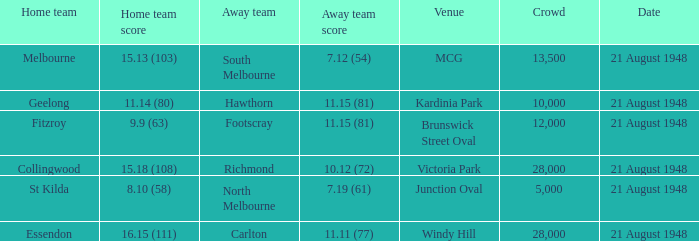With a home team score of 1 28000.0. Write the full table. {'header': ['Home team', 'Home team score', 'Away team', 'Away team score', 'Venue', 'Crowd', 'Date'], 'rows': [['Melbourne', '15.13 (103)', 'South Melbourne', '7.12 (54)', 'MCG', '13,500', '21 August 1948'], ['Geelong', '11.14 (80)', 'Hawthorn', '11.15 (81)', 'Kardinia Park', '10,000', '21 August 1948'], ['Fitzroy', '9.9 (63)', 'Footscray', '11.15 (81)', 'Brunswick Street Oval', '12,000', '21 August 1948'], ['Collingwood', '15.18 (108)', 'Richmond', '10.12 (72)', 'Victoria Park', '28,000', '21 August 1948'], ['St Kilda', '8.10 (58)', 'North Melbourne', '7.19 (61)', 'Junction Oval', '5,000', '21 August 1948'], ['Essendon', '16.15 (111)', 'Carlton', '11.11 (77)', 'Windy Hill', '28,000', '21 August 1948']]} 